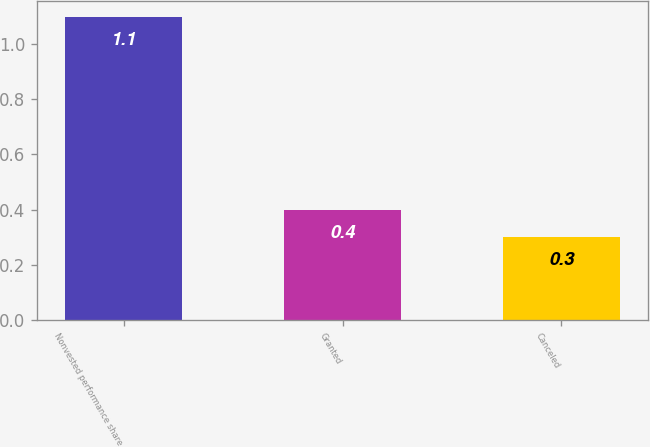<chart> <loc_0><loc_0><loc_500><loc_500><bar_chart><fcel>Nonvested performance share<fcel>Granted<fcel>Canceled<nl><fcel>1.1<fcel>0.4<fcel>0.3<nl></chart> 